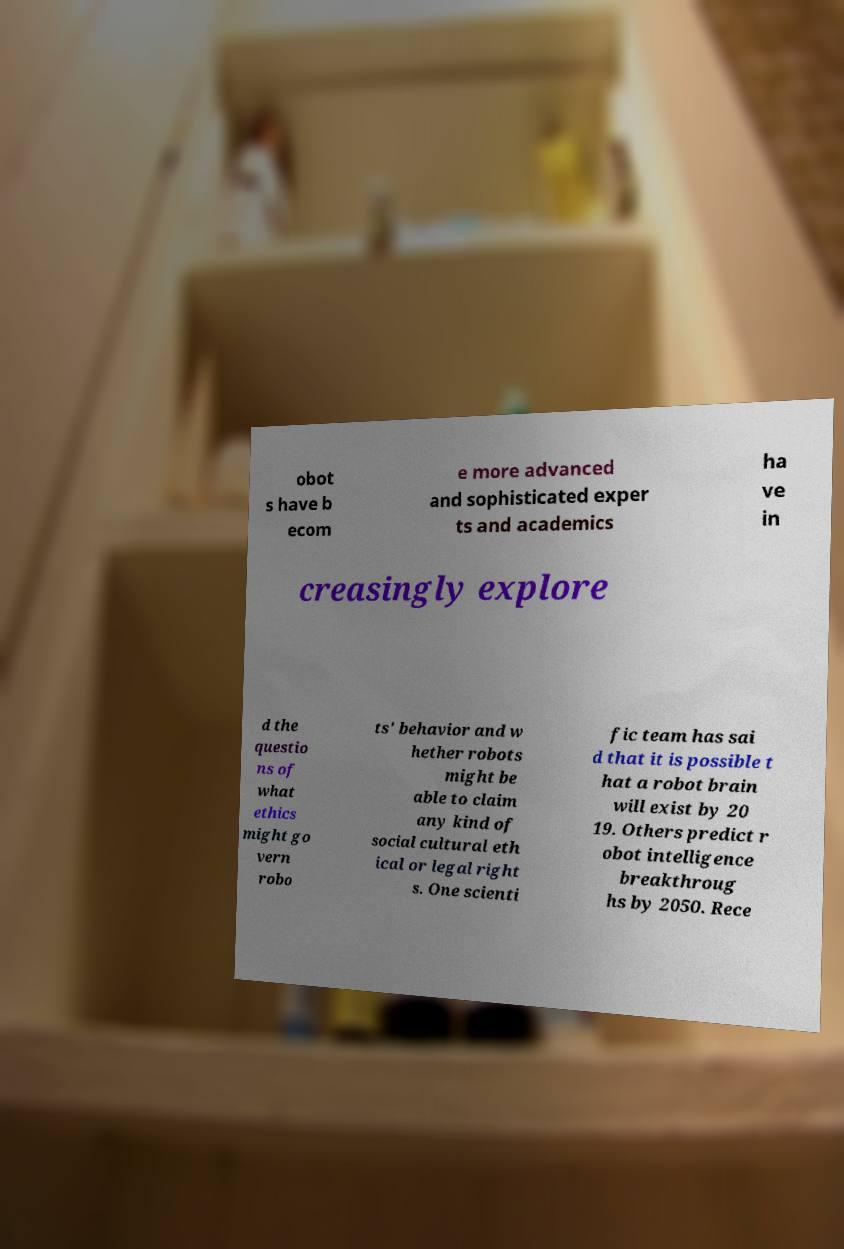Please read and relay the text visible in this image. What does it say? obot s have b ecom e more advanced and sophisticated exper ts and academics ha ve in creasingly explore d the questio ns of what ethics might go vern robo ts' behavior and w hether robots might be able to claim any kind of social cultural eth ical or legal right s. One scienti fic team has sai d that it is possible t hat a robot brain will exist by 20 19. Others predict r obot intelligence breakthroug hs by 2050. Rece 